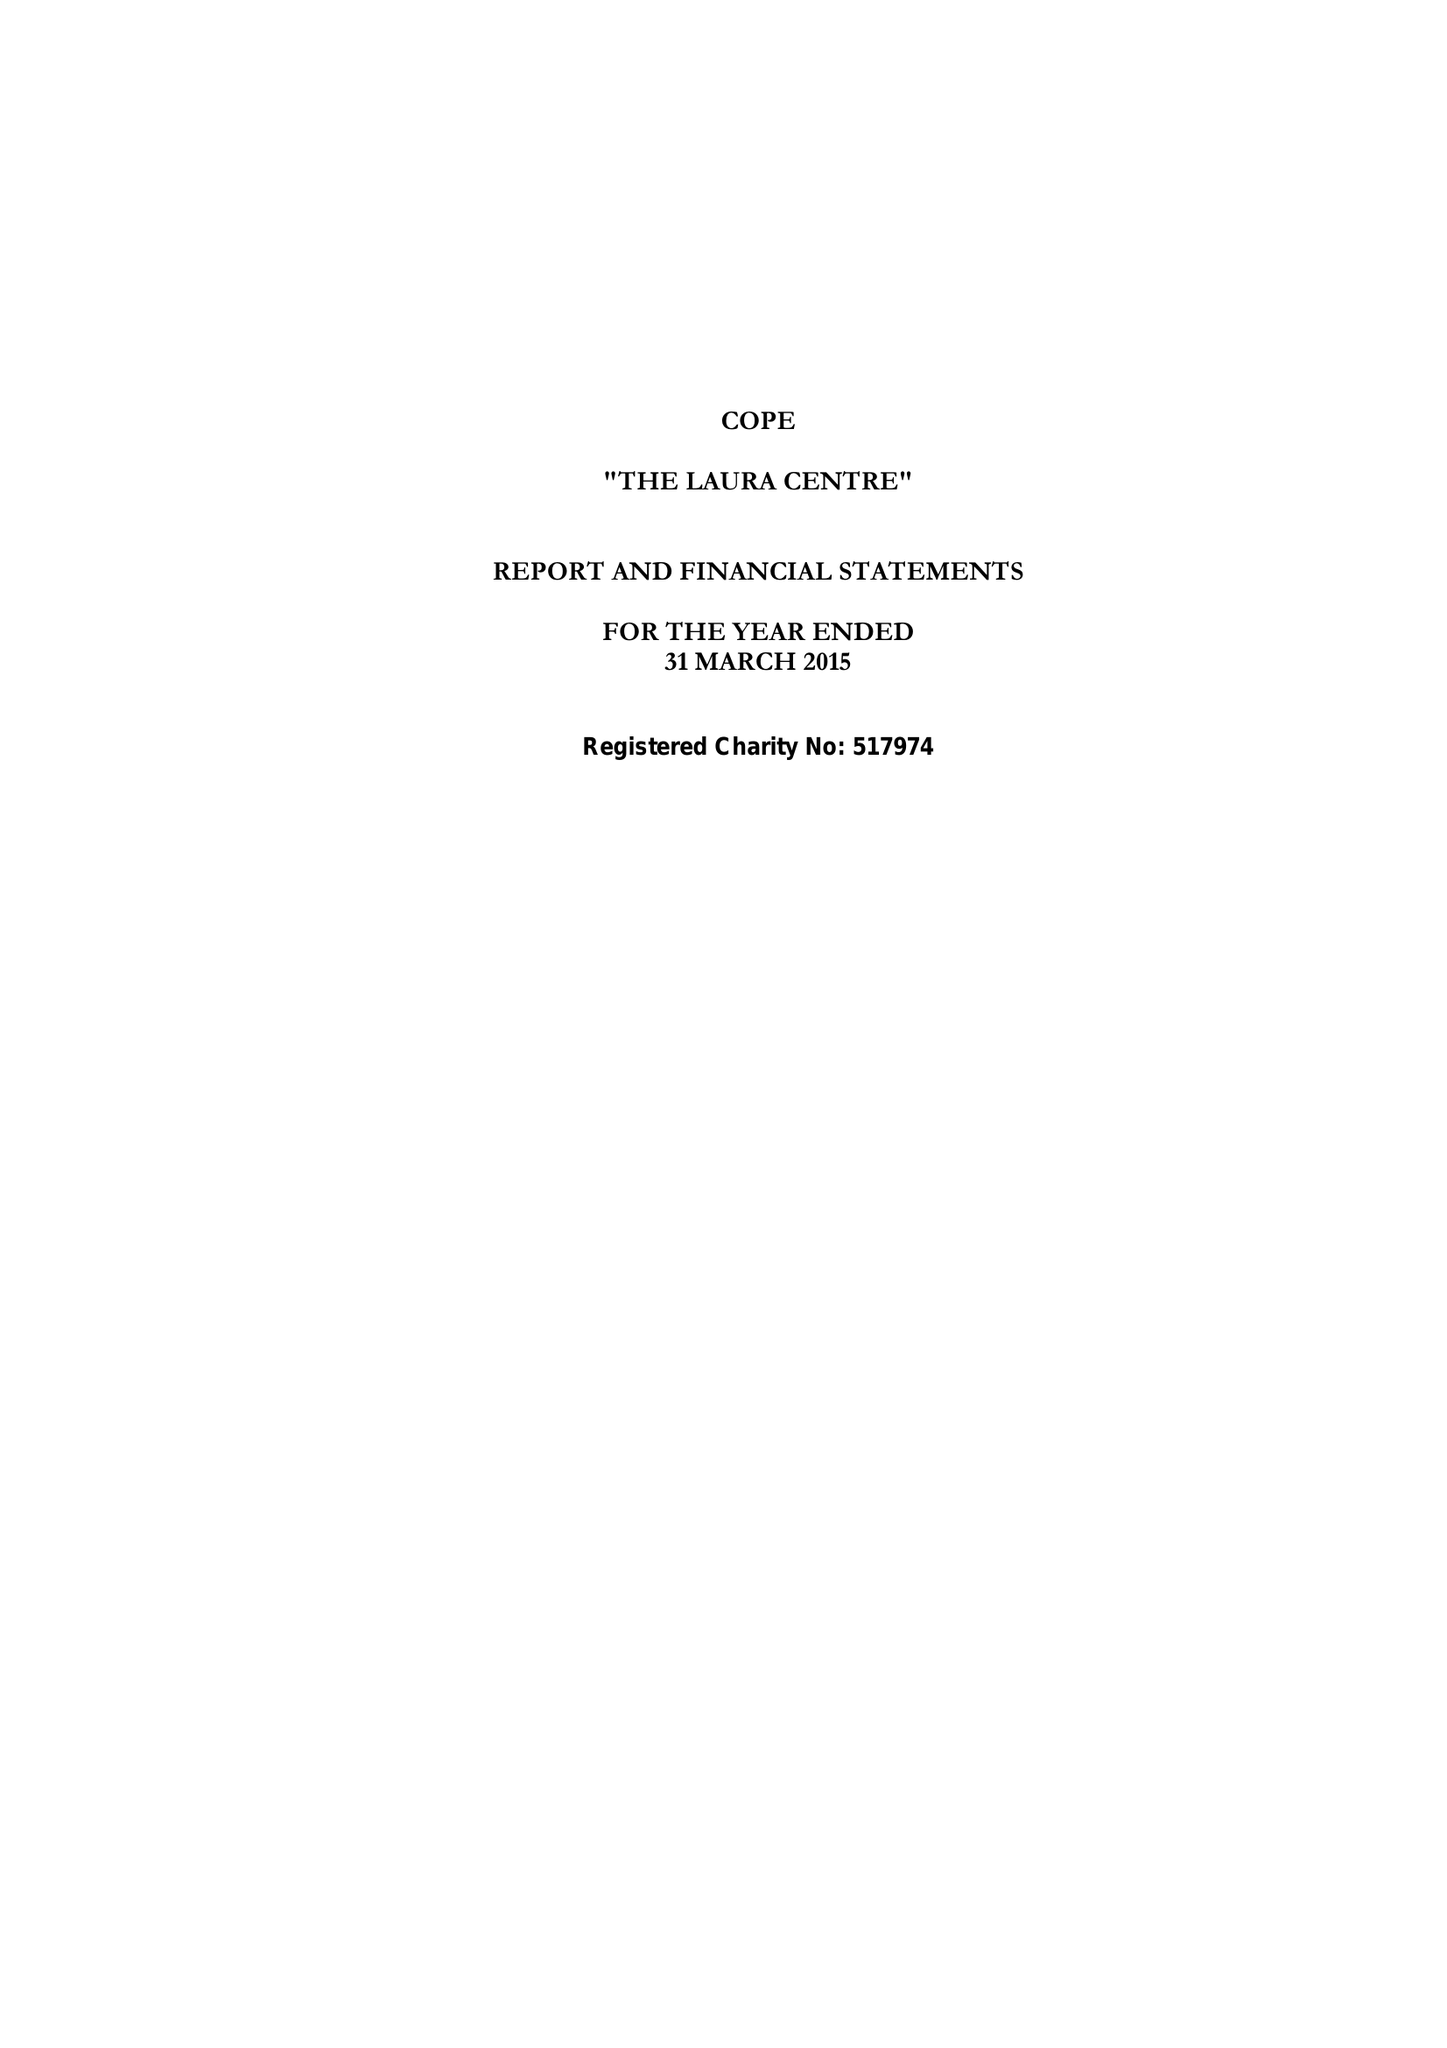What is the value for the charity_name?
Answer the question using a single word or phrase. Cope 